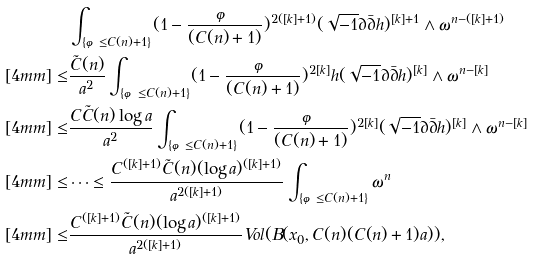Convert formula to latex. <formula><loc_0><loc_0><loc_500><loc_500>& \int _ { \{ \varphi \leq C ( n ) + 1 \} } ( 1 - \frac { \varphi } { ( C ( n ) + 1 ) } ) ^ { 2 ( [ k ] + 1 ) } ( \sqrt { - 1 } \partial \bar { \partial } h ) ^ { [ k ] + 1 } \wedge \omega ^ { n - ( [ k ] + 1 ) } \\ [ 4 m m ] \leq & \frac { \tilde { C } ( n ) } { a ^ { 2 } } \int _ { \{ \varphi \leq C ( n ) + 1 \} } ( 1 - \frac { \varphi } { ( C ( n ) + 1 ) } ) ^ { 2 [ k ] } h ( \sqrt { - 1 } \partial \bar { \partial } h ) ^ { [ k ] } \wedge \omega ^ { n - [ k ] } \\ [ 4 m m ] \leq & \frac { C \tilde { C } ( n ) \log a } { a ^ { 2 } } \int _ { \{ \varphi \leq C ( n ) + 1 \} } ( 1 - \frac { \varphi } { ( C ( n ) + 1 ) } ) ^ { 2 [ k ] } ( \sqrt { - 1 } \partial \bar { \partial } h ) ^ { [ k ] } \wedge \omega ^ { n - [ k ] } \\ [ 4 m m ] \leq & \cdots \leq \frac { C ^ { ( [ k ] + 1 ) } \tilde { C } ( n ) ( \log a ) ^ { ( [ k ] + 1 ) } } { a ^ { 2 ( [ k ] + 1 ) } } \int _ { \{ \varphi \leq C ( n ) + 1 \} } \omega ^ { n } \\ [ 4 m m ] \leq & \frac { C ^ { ( [ k ] + 1 ) } \tilde { C } ( n ) ( \log a ) ^ { ( [ k ] + 1 ) } } { a ^ { 2 ( [ k ] + 1 ) } } V o l ( B ( x _ { 0 } , C ( n ) ( C ( n ) + 1 ) a ) ) ,</formula> 